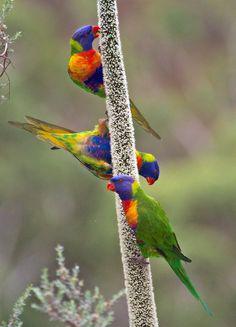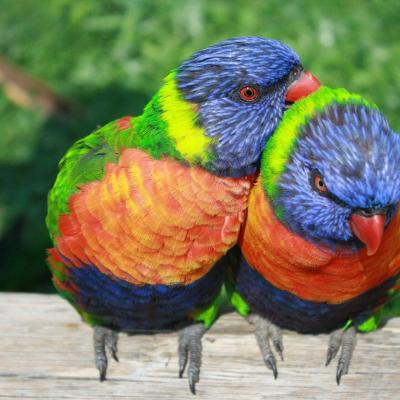The first image is the image on the left, the second image is the image on the right. Assess this claim about the two images: "A single bird perches on a branch outside in one of the images.". Correct or not? Answer yes or no. No. The first image is the image on the left, the second image is the image on the right. Evaluate the accuracy of this statement regarding the images: "At least one image shows a group of parrots around some kind of round container for food or drink.". Is it true? Answer yes or no. No. 